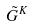Convert formula to latex. <formula><loc_0><loc_0><loc_500><loc_500>\tilde { G } ^ { K }</formula> 